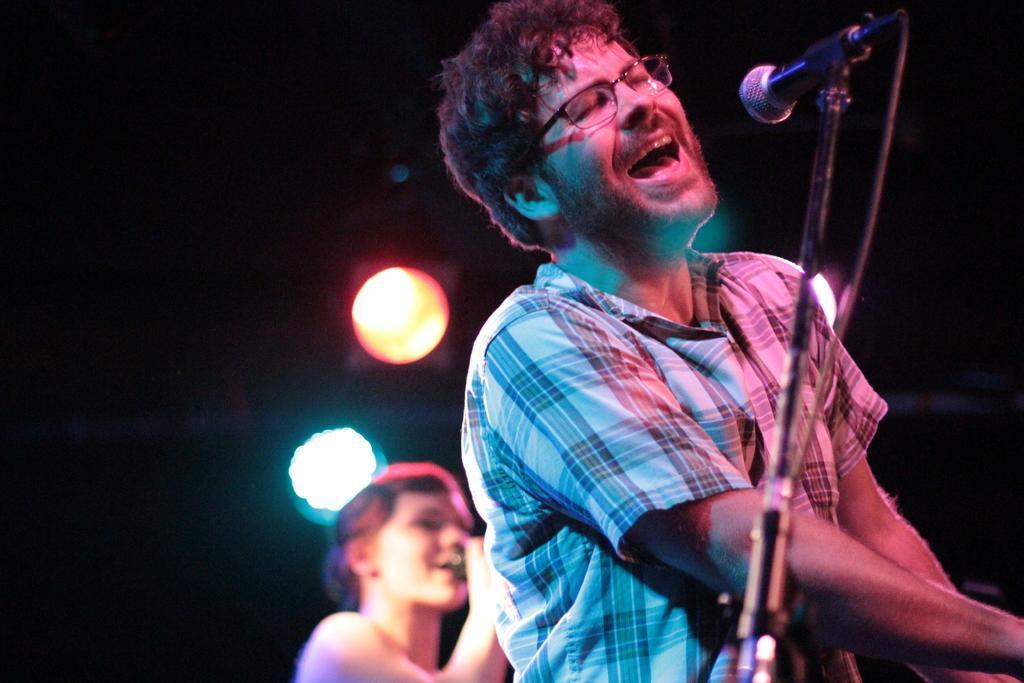Describe this image in one or two sentences. Here a man is singing in the microphone, he wore shirt, spectacles. Here a woman is also singing, in the middle there are focus lights. 